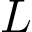<formula> <loc_0><loc_0><loc_500><loc_500>L</formula> 